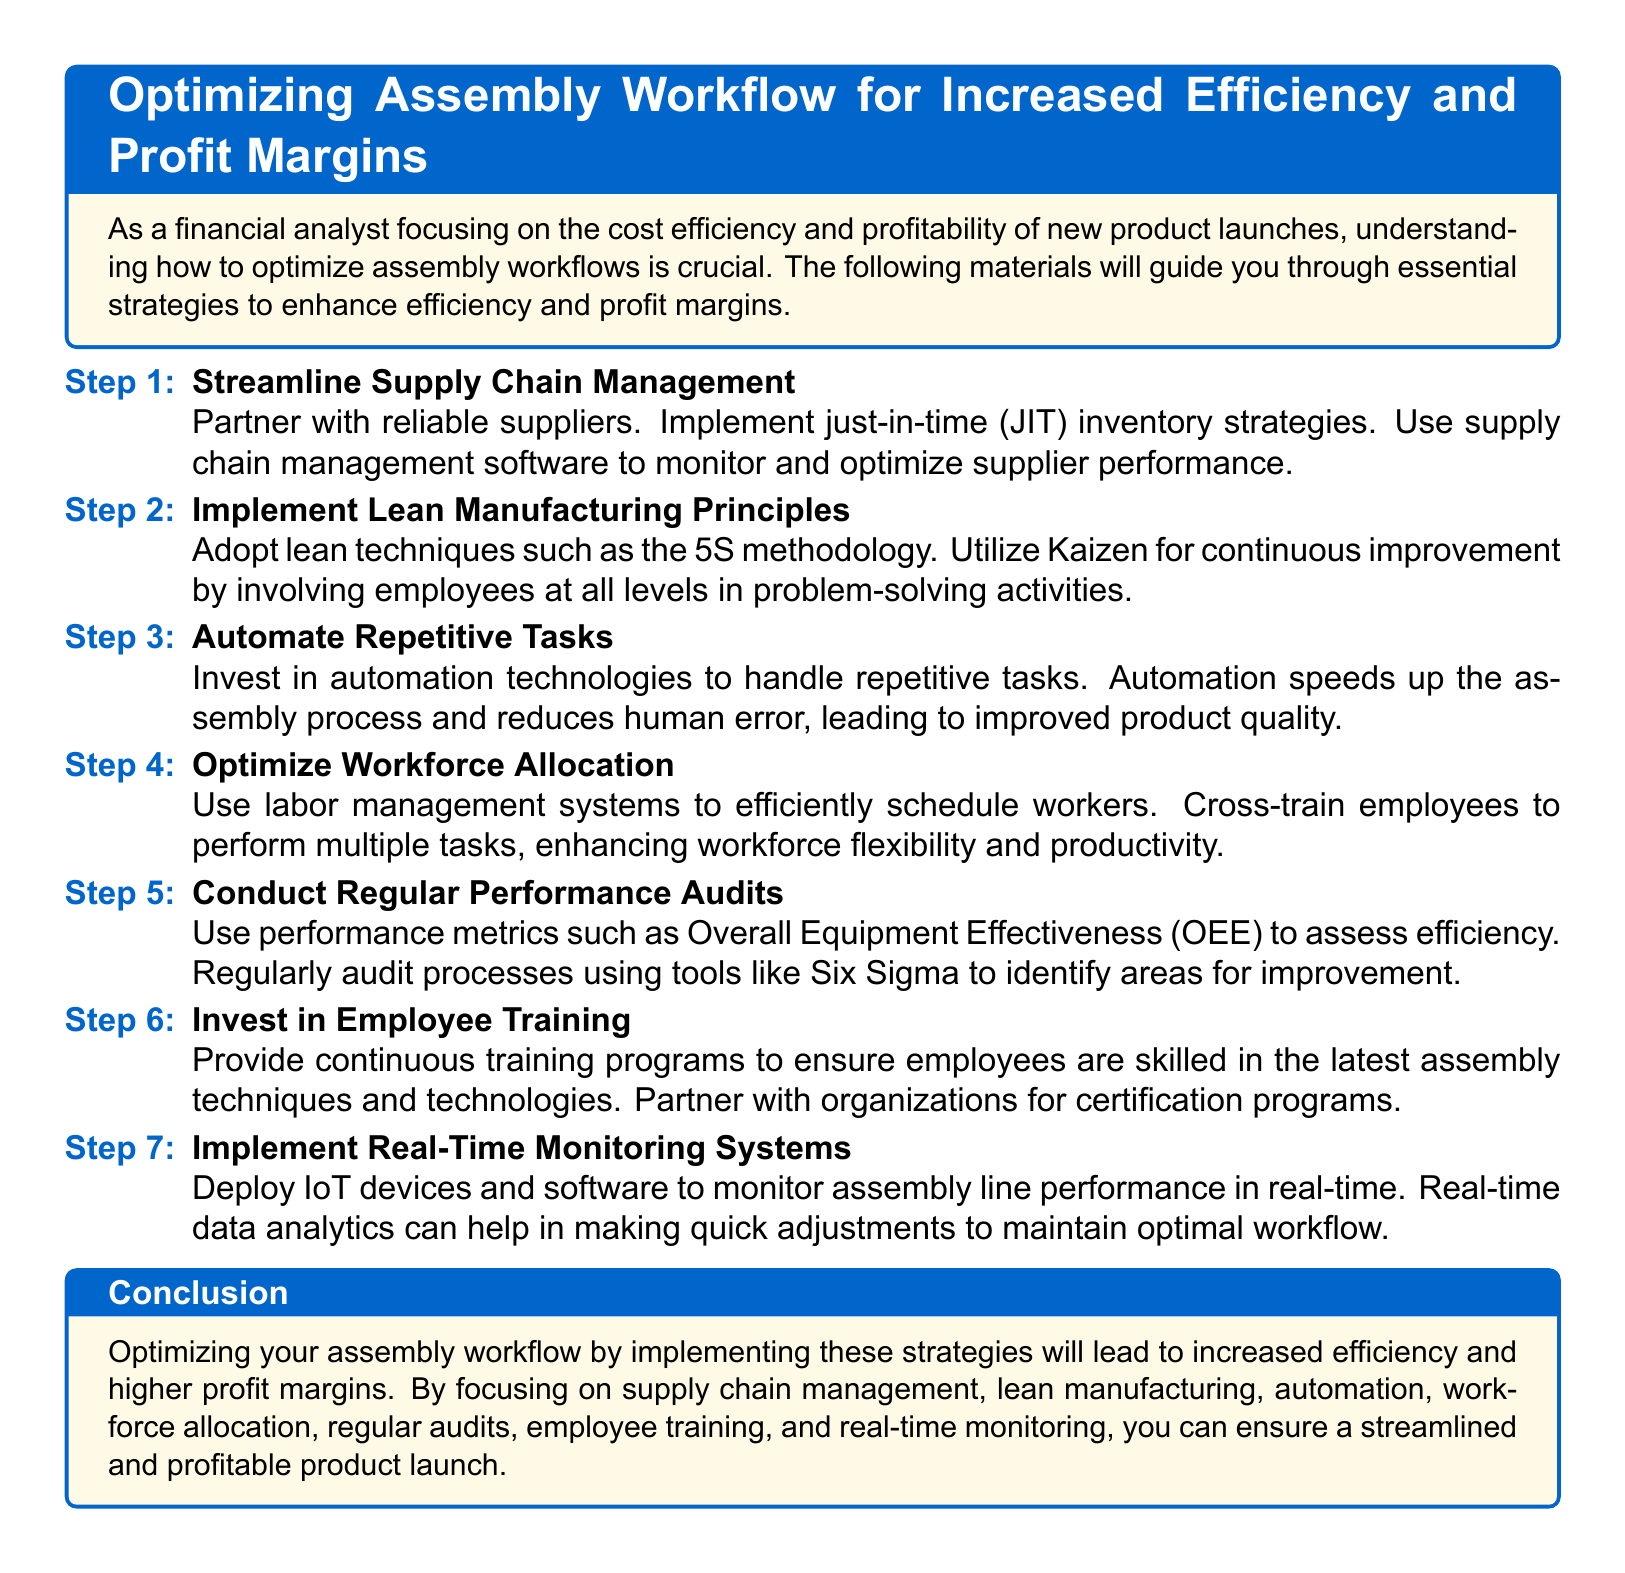What is the title of the document? The title presents the main subject of the document and is indicated at the top of the rendered content.
Answer: Optimizing Assembly Workflow for Increased Efficiency and Profit Margins What is one strategy mentioned for improving supply chain management? The document lists strategies for supply chain management that improve efficiency, specifically mentioning a method that minimizes excess inventory.
Answer: Just-in-time (JIT) inventory strategies Which methodology is mentioned for implementing lean manufacturing principles? The document refers to specific methodologies used in lean manufacturing principles, one of which is a popular organizational method.
Answer: 5S methodology What is the purpose of conducting regular performance audits? The document outlines the purpose of performance audits in assessing the efficiency of the assembly process and improving it over time.
Answer: Assess efficiency Name one technology suggested for automating tasks. The document advises investing in specific technologies that help in streamlining repetitive assembly tasks, thereby improving efficiency.
Answer: Automation technologies How often should employee training programs be provided? The document implies that training is essential but does not specify a frequency, focusing more on the importance of ongoing education.
Answer: Continuous What is the abbreviation for Overall Equipment Effectiveness? The document discusses metrics for evaluating performance and mentions a specific abbreviation that stands for Overall Equipment Effectiveness.
Answer: OEE What type of systems should be implemented for real-time monitoring? The document suggests using certain devices and software solutions that facilitate the monitoring of workflow as it happens.
Answer: IoT devices and software What is the main focus of the document? The document's content revolves around a central topic that emphasizes improving operational performance and profitability during product assembly.
Answer: Efficiency and profit margins 